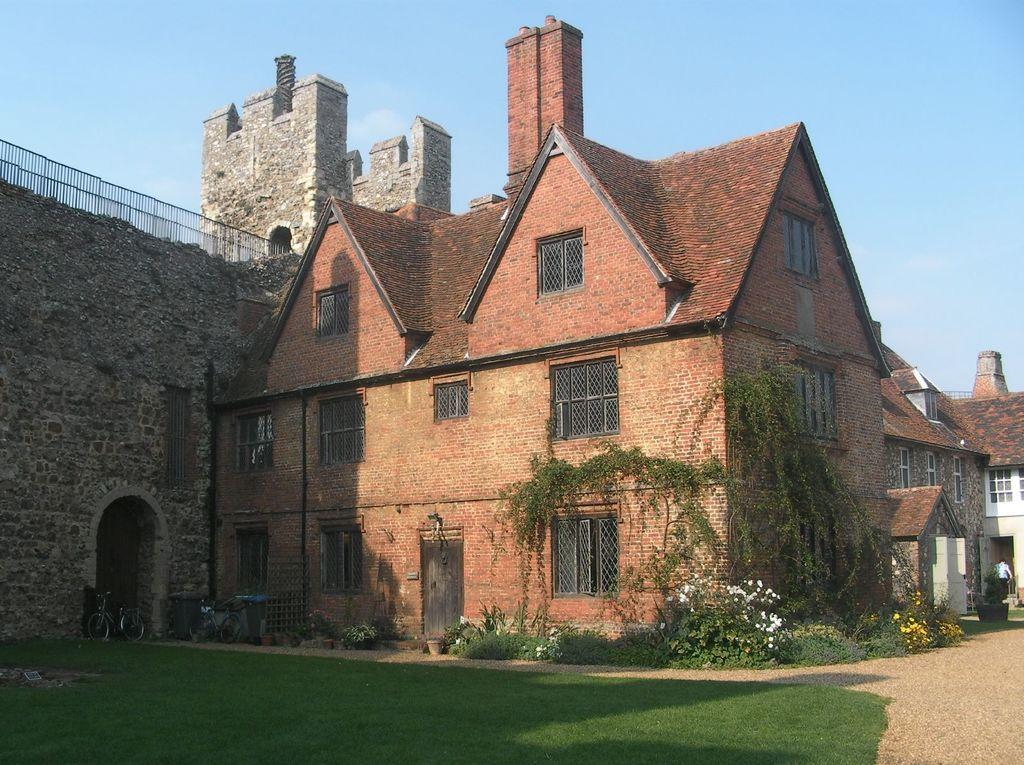Please provide a concise description of this image. In this image we can see the castle, some plants with flowers, some plants on the castle wall, two bicycles on the ground, some pots with plants, some objects on the ground, few objects attached to the castle, it looks like two fences attached to the castle, one man walking, some plants, bushes and grass on the ground. At the top there is the cloudy sky. 